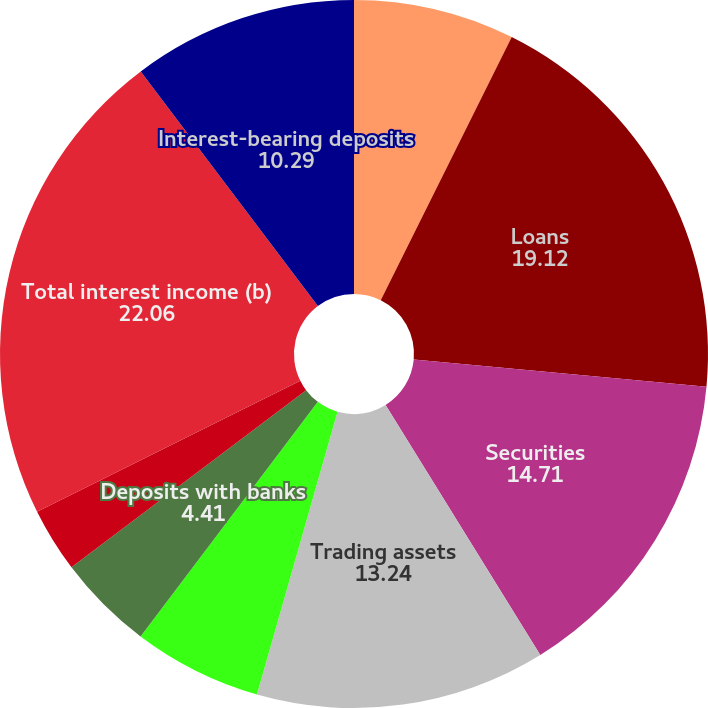Convert chart. <chart><loc_0><loc_0><loc_500><loc_500><pie_chart><fcel>Year ended December 31 (in<fcel>Loans<fcel>Securities<fcel>Trading assets<fcel>Federal funds sold and<fcel>Securities borrowed<fcel>Deposits with banks<fcel>Other assets (a)<fcel>Total interest income (b)<fcel>Interest-bearing deposits<nl><fcel>7.35%<fcel>19.12%<fcel>14.71%<fcel>13.24%<fcel>5.88%<fcel>0.0%<fcel>4.41%<fcel>2.94%<fcel>22.06%<fcel>10.29%<nl></chart> 